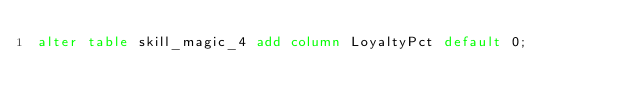<code> <loc_0><loc_0><loc_500><loc_500><_SQL_>alter table skill_magic_4 add column LoyaltyPct default 0;
</code> 